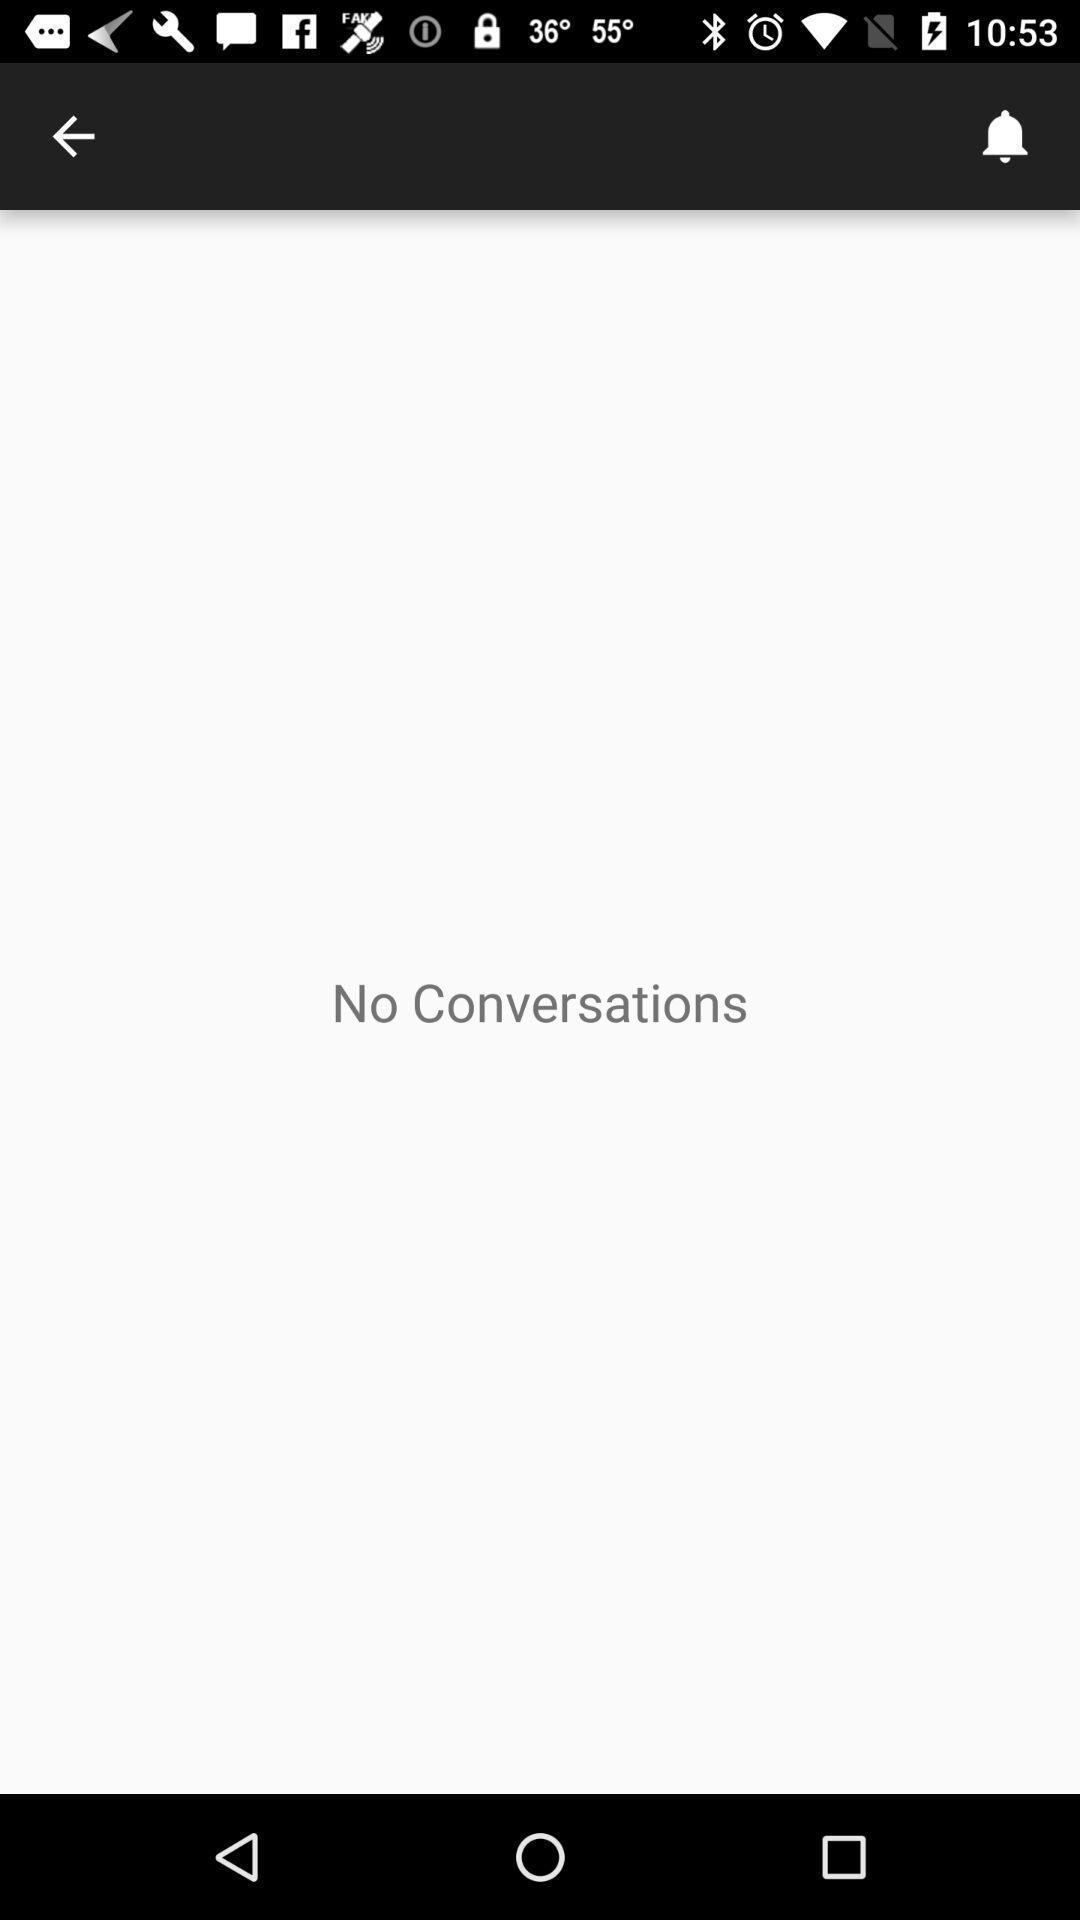Describe the key features of this screenshot. Screen showing the no conversations in social app. 